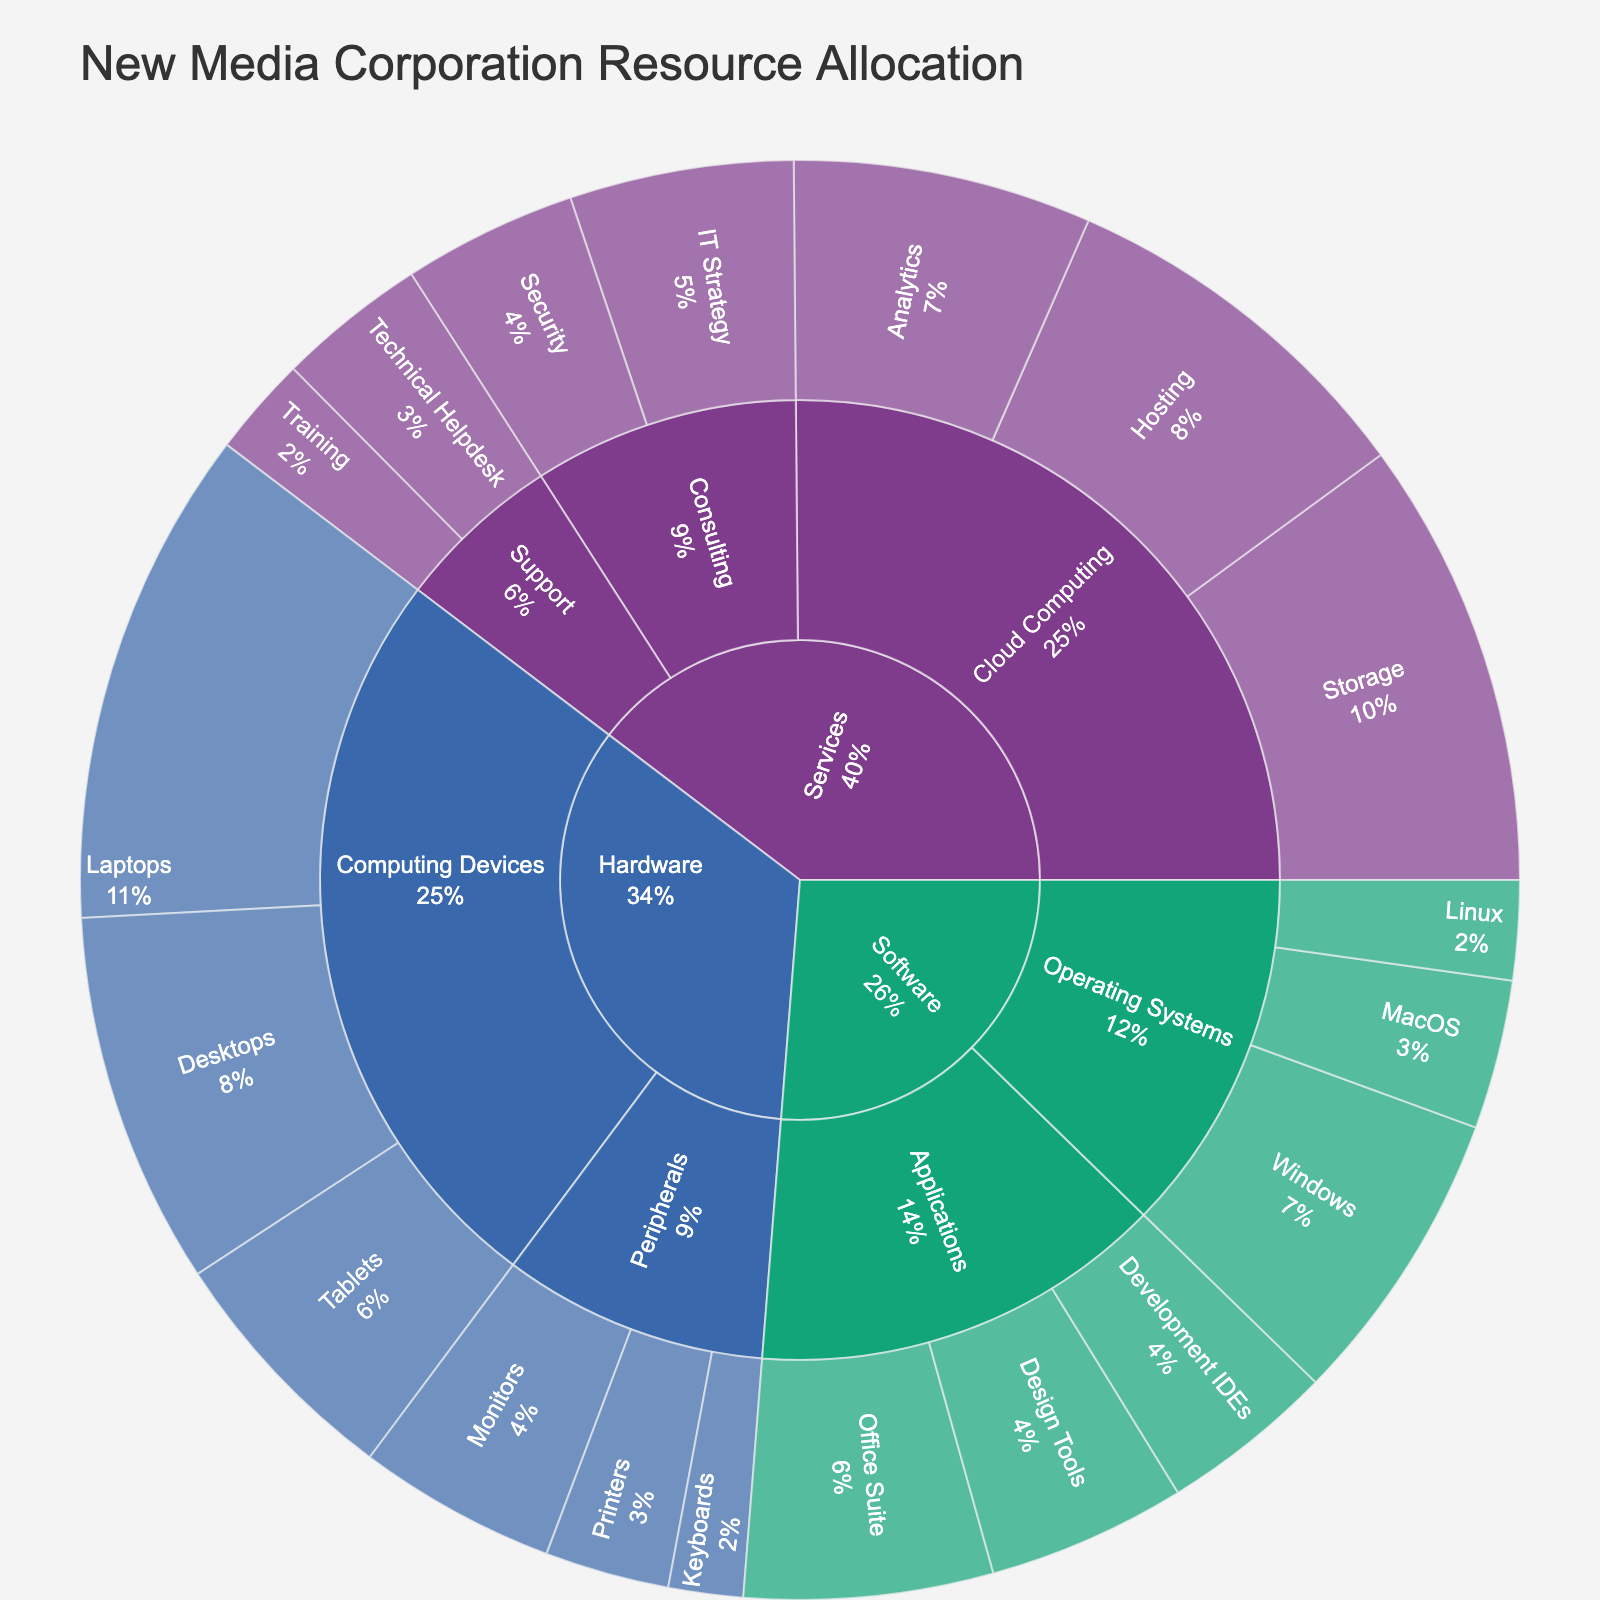What is the title of the plot? The title of the plot is displayed at the top.
Answer: New Media Corporation Resource Allocation How many products are listed in the plot? The sunburst plot shows three main products, which are highlighted by different colors.
Answer: 3 Which category under Hardware has the highest value? The categories under Hardware are "Computing Devices" and "Peripherals." Compare the values under each category to identify the highest one. "Computing Devices" has values of 15 (Desktops), 20 (Laptops), and 10 (Tablets), total 45. "Peripherals" has 8 (Monitors), 5 (Printers), and 3 (Keyboards), total 16. Therefore, "Computing Devices" has the highest value.
Answer: Computing Devices What is the value associated with the Windows subcategory in the Software category? Look for the value labeled directly under Windows in the Software-Operating Systems branch.
Answer: 12 What is the total value for the Consulting category under Services? The Consulting category includes "IT Strategy" with a value of 9 and "Security" with a value of 7. Summing these gives 9 + 7.
Answer: 16 Which has a higher value: Cloud Computing under Services or Applications under Software? Calculate the total values for both categories. Cloud Computing: Storage (18) + Hosting (15) + Analytics (12) = 45. Applications: Office Suite (10) + Design Tools (8) + Development IDEs (7) = 25. Compare the totals to determine which is higher.
Answer: Cloud Computing What percentage of the Hardware allocation is dedicated to Peripherals? The total value for Hardware is 61. The value for Peripherals is 16. To find the percentage: (16 / 61) * 100%.
Answer: Approximately 26.2% Which subcategory under Services has the lowest value, and what is that value? Under the Services category, examine all the subcategories and their values: Storage (18), Hosting (15), Analytics (12), IT Strategy (9), Security (7), Technical Helpdesk (6), Training (4). Identify the lowest value, which is 4, under Training.
Answer: Training, 4 How does the Office Suite allocation compare to the Linux allocation? Identify the values for Office Suite (10) and Linux (4). Office Suite has a higher value than Linux.
Answer: Office Suite has a higher value What is the combined value of the computing devices? The computing devices include Desktops (15), Laptops (20), and Tablets (10). Sum these values: 15 + 20 + 10.
Answer: 45 